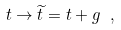<formula> <loc_0><loc_0><loc_500><loc_500>t \rightarrow \widetilde { t } = t + g \ ,</formula> 